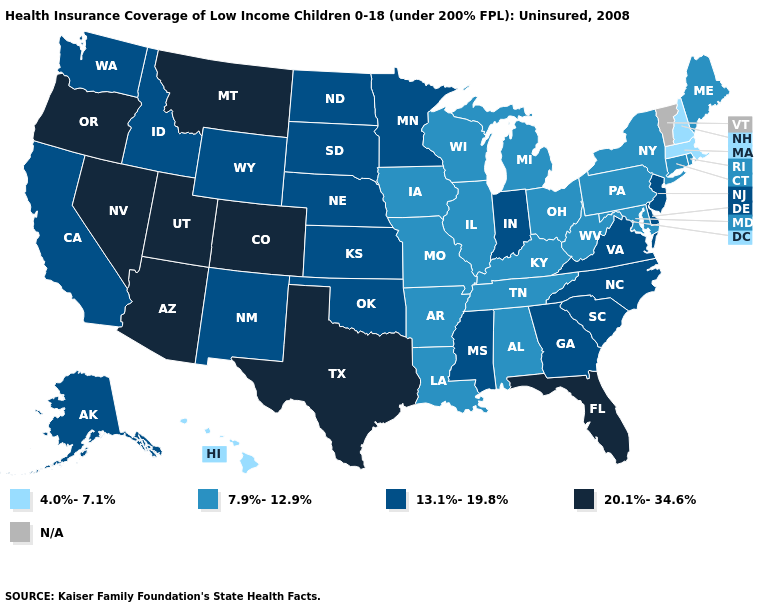Name the states that have a value in the range 4.0%-7.1%?
Answer briefly. Hawaii, Massachusetts, New Hampshire. Name the states that have a value in the range N/A?
Concise answer only. Vermont. Does the map have missing data?
Quick response, please. Yes. How many symbols are there in the legend?
Short answer required. 5. Name the states that have a value in the range 20.1%-34.6%?
Give a very brief answer. Arizona, Colorado, Florida, Montana, Nevada, Oregon, Texas, Utah. What is the value of Colorado?
Short answer required. 20.1%-34.6%. What is the value of Maryland?
Concise answer only. 7.9%-12.9%. What is the lowest value in the USA?
Keep it brief. 4.0%-7.1%. What is the highest value in the MidWest ?
Give a very brief answer. 13.1%-19.8%. Among the states that border Massachusetts , which have the highest value?
Quick response, please. Connecticut, New York, Rhode Island. What is the value of Minnesota?
Answer briefly. 13.1%-19.8%. Does the first symbol in the legend represent the smallest category?
Be succinct. Yes. Which states have the lowest value in the USA?
Answer briefly. Hawaii, Massachusetts, New Hampshire. 